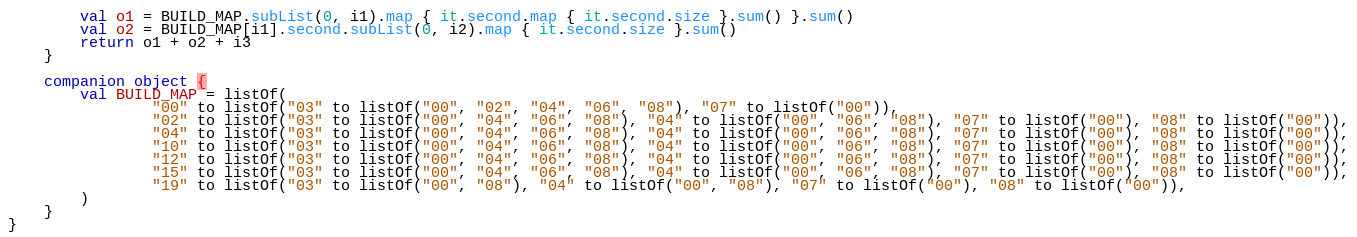<code> <loc_0><loc_0><loc_500><loc_500><_Kotlin_>        val o1 = BUILD_MAP.subList(0, i1).map { it.second.map { it.second.size }.sum() }.sum()
        val o2 = BUILD_MAP[i1].second.subList(0, i2).map { it.second.size }.sum()
        return o1 + o2 + i3
    }

    companion object {
        val BUILD_MAP = listOf(
                "00" to listOf("03" to listOf("00", "02", "04", "06", "08"), "07" to listOf("00")),
                "02" to listOf("03" to listOf("00", "04", "06", "08"), "04" to listOf("00", "06", "08"), "07" to listOf("00"), "08" to listOf("00")),
                "04" to listOf("03" to listOf("00", "04", "06", "08"), "04" to listOf("00", "06", "08"), "07" to listOf("00"), "08" to listOf("00")),
                "10" to listOf("03" to listOf("00", "04", "06", "08"), "04" to listOf("00", "06", "08"), "07" to listOf("00"), "08" to listOf("00")),
                "12" to listOf("03" to listOf("00", "04", "06", "08"), "04" to listOf("00", "06", "08"), "07" to listOf("00"), "08" to listOf("00")),
                "15" to listOf("03" to listOf("00", "04", "06", "08"), "04" to listOf("00", "06", "08"), "07" to listOf("00"), "08" to listOf("00")),
                "19" to listOf("03" to listOf("00", "08"), "04" to listOf("00", "08"), "07" to listOf("00"), "08" to listOf("00")),
        )
    }
}
</code> 